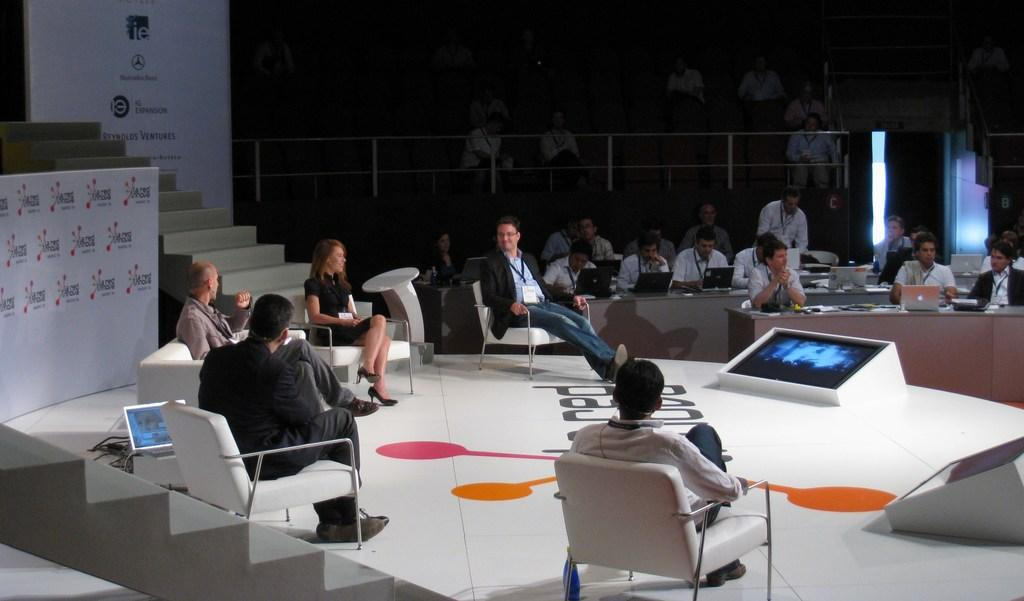What are the people in the image doing? There is a group of people sitting in the image. What architectural feature can be seen in the image? There are stairs in the image. Who is present in the image besides the group of people? There is an audience in the image. What electronic device is located beside a chair in the image? There is a monitor beside a chair in the image. What type of top is the partner wearing in the image? There is no partner present in the image, and therefore no clothing can be described. 